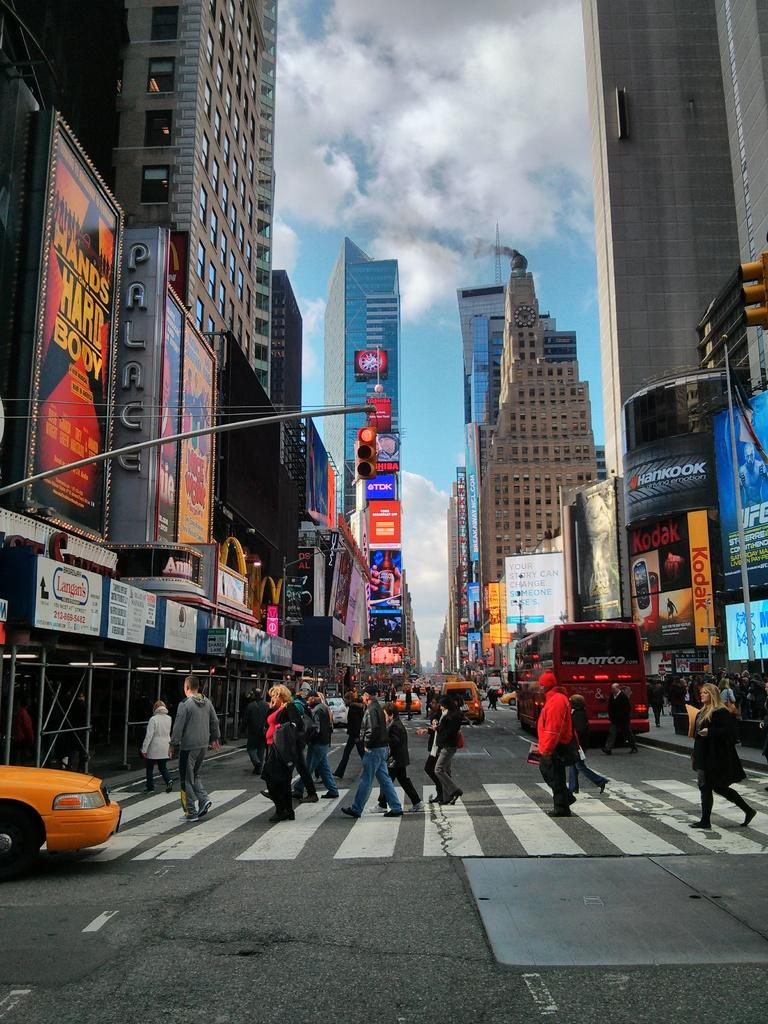<image>
Provide a brief description of the given image. Many people walking in Times Square and, a large billboard reading Hands on a Hard Body. 